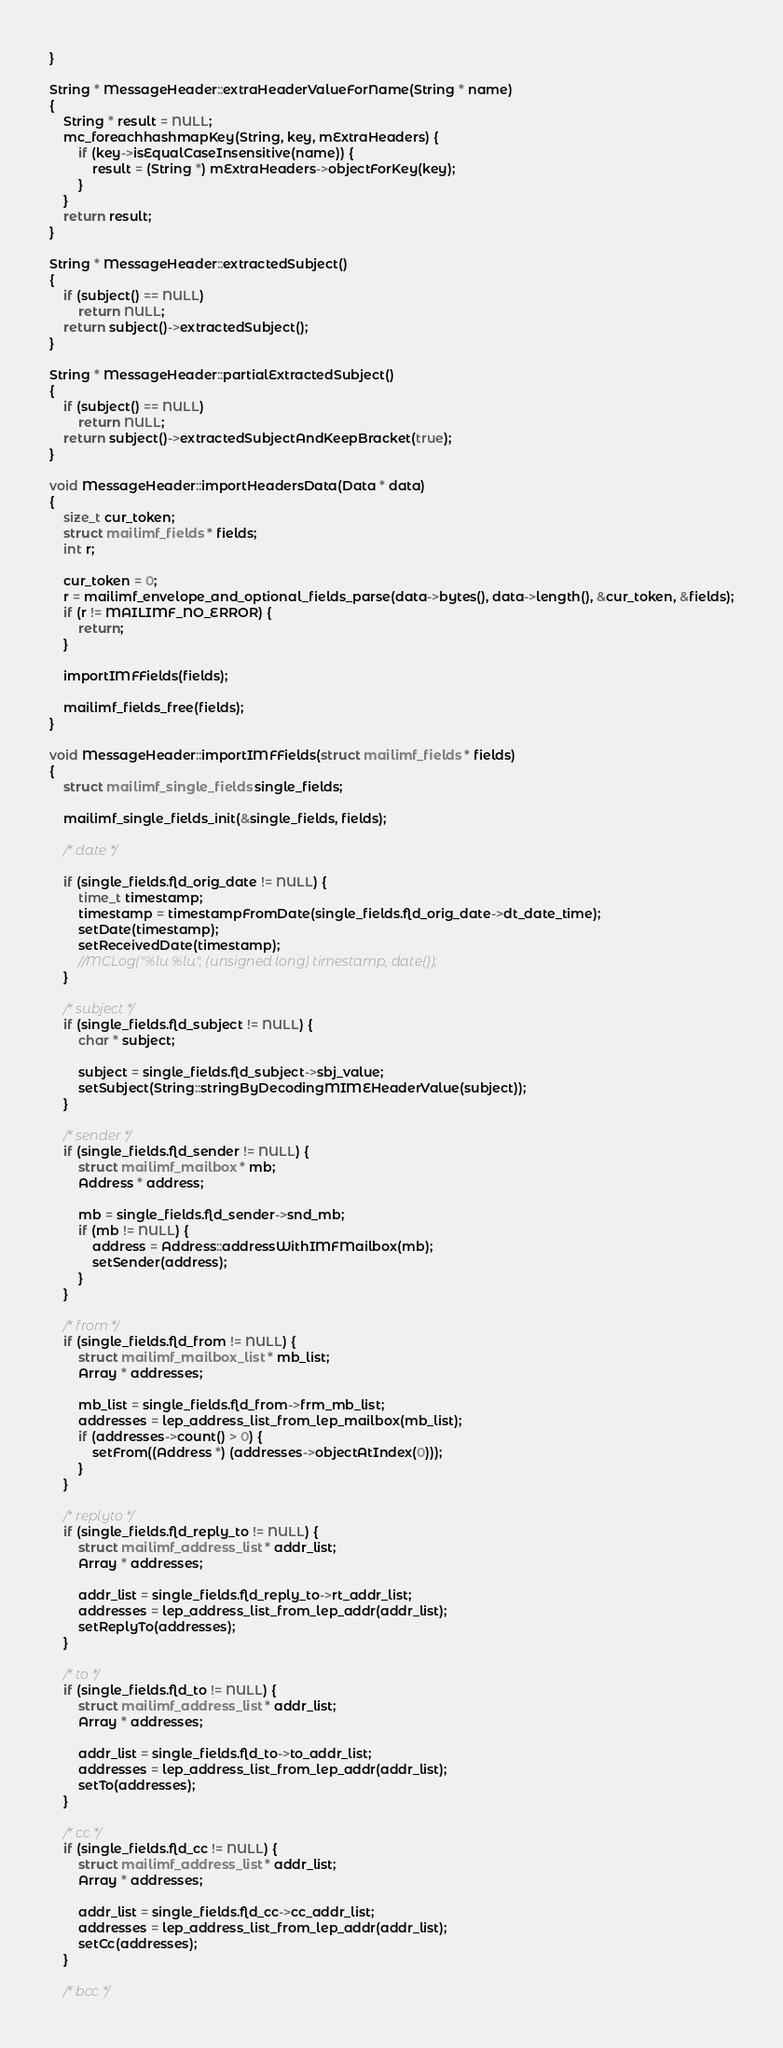Convert code to text. <code><loc_0><loc_0><loc_500><loc_500><_C++_>}

String * MessageHeader::extraHeaderValueForName(String * name)
{
    String * result = NULL;
    mc_foreachhashmapKey(String, key, mExtraHeaders) {
        if (key->isEqualCaseInsensitive(name)) {
            result = (String *) mExtraHeaders->objectForKey(key);
        }
    }
    return result;
}

String * MessageHeader::extractedSubject()
{
    if (subject() == NULL)
        return NULL;
    return subject()->extractedSubject();
}

String * MessageHeader::partialExtractedSubject()
{
    if (subject() == NULL)
        return NULL;
    return subject()->extractedSubjectAndKeepBracket(true);
}

void MessageHeader::importHeadersData(Data * data)
{
    size_t cur_token;
    struct mailimf_fields * fields;
    int r;
    
    cur_token = 0;
    r = mailimf_envelope_and_optional_fields_parse(data->bytes(), data->length(), &cur_token, &fields);
    if (r != MAILIMF_NO_ERROR) {
        return;
    }
    
    importIMFFields(fields);

    mailimf_fields_free(fields);
}

void MessageHeader::importIMFFields(struct mailimf_fields * fields)
{
    struct mailimf_single_fields single_fields;
    
    mailimf_single_fields_init(&single_fields, fields);
    
    /* date */
    
    if (single_fields.fld_orig_date != NULL) {
        time_t timestamp;
        timestamp = timestampFromDate(single_fields.fld_orig_date->dt_date_time);
        setDate(timestamp);
        setReceivedDate(timestamp);
        //MCLog("%lu %lu", (unsigned long) timestamp, date());
    }
    
    /* subject */
    if (single_fields.fld_subject != NULL) {
        char * subject;
        
        subject = single_fields.fld_subject->sbj_value;
        setSubject(String::stringByDecodingMIMEHeaderValue(subject));
    }
    
    /* sender */
    if (single_fields.fld_sender != NULL) {
        struct mailimf_mailbox * mb;
        Address * address;
        
        mb = single_fields.fld_sender->snd_mb;
        if (mb != NULL) {
            address = Address::addressWithIMFMailbox(mb);
            setSender(address);
        }
    }
    
    /* from */
    if (single_fields.fld_from != NULL) {
        struct mailimf_mailbox_list * mb_list;
        Array * addresses;
        
        mb_list = single_fields.fld_from->frm_mb_list;
        addresses = lep_address_list_from_lep_mailbox(mb_list);
        if (addresses->count() > 0) {
            setFrom((Address *) (addresses->objectAtIndex(0)));
        }
    }
    
    /* replyto */
    if (single_fields.fld_reply_to != NULL) {
        struct mailimf_address_list * addr_list;
        Array * addresses;
        
        addr_list = single_fields.fld_reply_to->rt_addr_list;
        addresses = lep_address_list_from_lep_addr(addr_list);
        setReplyTo(addresses);
    }
    
    /* to */
    if (single_fields.fld_to != NULL) {
        struct mailimf_address_list * addr_list;
        Array * addresses;
        
        addr_list = single_fields.fld_to->to_addr_list;
        addresses = lep_address_list_from_lep_addr(addr_list);
        setTo(addresses);
    }
    
    /* cc */
    if (single_fields.fld_cc != NULL) {
        struct mailimf_address_list * addr_list;
        Array * addresses;
        
        addr_list = single_fields.fld_cc->cc_addr_list;
        addresses = lep_address_list_from_lep_addr(addr_list);
        setCc(addresses);
    }
    
    /* bcc */</code> 